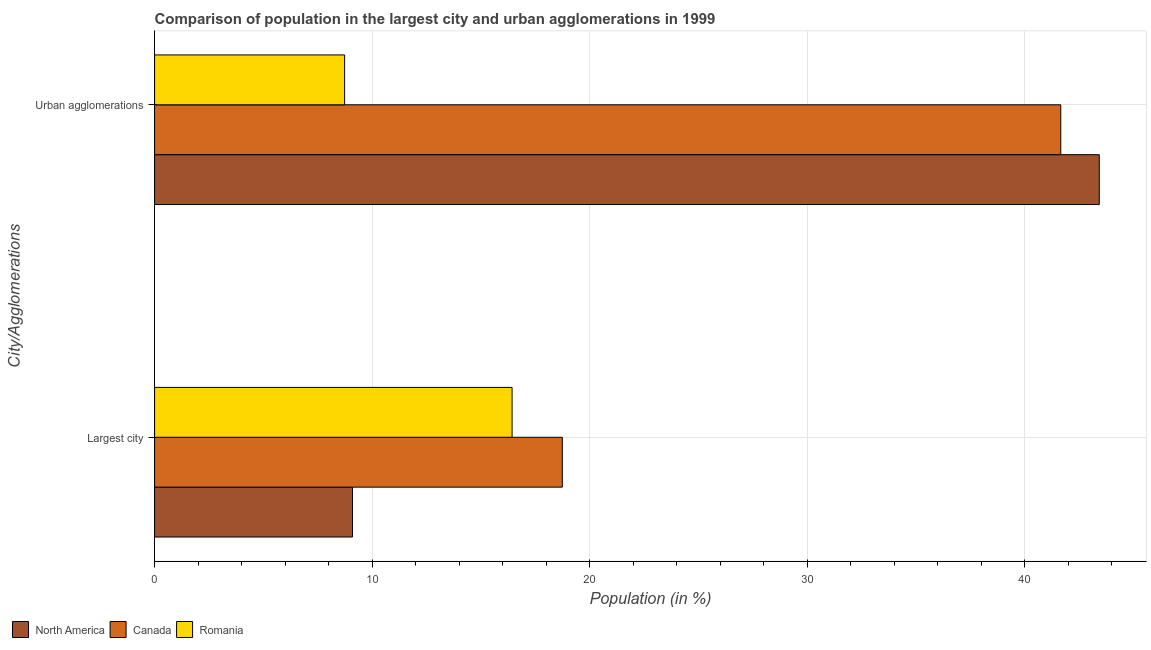How many different coloured bars are there?
Your answer should be very brief. 3. Are the number of bars per tick equal to the number of legend labels?
Provide a short and direct response. Yes. How many bars are there on the 2nd tick from the bottom?
Give a very brief answer. 3. What is the label of the 1st group of bars from the top?
Your answer should be compact. Urban agglomerations. What is the population in the largest city in North America?
Offer a very short reply. 9.1. Across all countries, what is the maximum population in urban agglomerations?
Provide a succinct answer. 43.42. Across all countries, what is the minimum population in the largest city?
Provide a succinct answer. 9.1. In which country was the population in urban agglomerations minimum?
Make the answer very short. Romania. What is the total population in urban agglomerations in the graph?
Make the answer very short. 93.81. What is the difference between the population in the largest city in Canada and that in Romania?
Your answer should be compact. 2.31. What is the difference between the population in urban agglomerations in Romania and the population in the largest city in Canada?
Offer a very short reply. -10.01. What is the average population in urban agglomerations per country?
Provide a succinct answer. 31.27. What is the difference between the population in the largest city and population in urban agglomerations in North America?
Keep it short and to the point. -34.32. What is the ratio of the population in urban agglomerations in Canada to that in North America?
Offer a very short reply. 0.96. Is the population in the largest city in North America less than that in Canada?
Your answer should be compact. Yes. What does the 3rd bar from the top in Largest city represents?
Ensure brevity in your answer.  North America. What does the 3rd bar from the bottom in Largest city represents?
Ensure brevity in your answer.  Romania. Does the graph contain any zero values?
Make the answer very short. No. Does the graph contain grids?
Offer a very short reply. Yes. Where does the legend appear in the graph?
Keep it short and to the point. Bottom left. How are the legend labels stacked?
Offer a very short reply. Horizontal. What is the title of the graph?
Make the answer very short. Comparison of population in the largest city and urban agglomerations in 1999. What is the label or title of the X-axis?
Ensure brevity in your answer.  Population (in %). What is the label or title of the Y-axis?
Provide a short and direct response. City/Agglomerations. What is the Population (in %) of North America in Largest city?
Your answer should be very brief. 9.1. What is the Population (in %) in Canada in Largest city?
Provide a short and direct response. 18.74. What is the Population (in %) in Romania in Largest city?
Offer a very short reply. 16.43. What is the Population (in %) in North America in Urban agglomerations?
Your answer should be compact. 43.42. What is the Population (in %) of Canada in Urban agglomerations?
Your response must be concise. 41.65. What is the Population (in %) in Romania in Urban agglomerations?
Offer a terse response. 8.74. Across all City/Agglomerations, what is the maximum Population (in %) in North America?
Make the answer very short. 43.42. Across all City/Agglomerations, what is the maximum Population (in %) of Canada?
Provide a short and direct response. 41.65. Across all City/Agglomerations, what is the maximum Population (in %) in Romania?
Your response must be concise. 16.43. Across all City/Agglomerations, what is the minimum Population (in %) in North America?
Ensure brevity in your answer.  9.1. Across all City/Agglomerations, what is the minimum Population (in %) of Canada?
Your answer should be very brief. 18.74. Across all City/Agglomerations, what is the minimum Population (in %) in Romania?
Keep it short and to the point. 8.74. What is the total Population (in %) of North America in the graph?
Offer a very short reply. 52.52. What is the total Population (in %) in Canada in the graph?
Offer a terse response. 60.39. What is the total Population (in %) of Romania in the graph?
Keep it short and to the point. 25.17. What is the difference between the Population (in %) of North America in Largest city and that in Urban agglomerations?
Make the answer very short. -34.32. What is the difference between the Population (in %) of Canada in Largest city and that in Urban agglomerations?
Keep it short and to the point. -22.91. What is the difference between the Population (in %) of Romania in Largest city and that in Urban agglomerations?
Keep it short and to the point. 7.7. What is the difference between the Population (in %) in North America in Largest city and the Population (in %) in Canada in Urban agglomerations?
Offer a terse response. -32.56. What is the difference between the Population (in %) in North America in Largest city and the Population (in %) in Romania in Urban agglomerations?
Your answer should be very brief. 0.36. What is the difference between the Population (in %) in Canada in Largest city and the Population (in %) in Romania in Urban agglomerations?
Offer a very short reply. 10.01. What is the average Population (in %) in North America per City/Agglomerations?
Provide a short and direct response. 26.26. What is the average Population (in %) of Canada per City/Agglomerations?
Offer a terse response. 30.2. What is the average Population (in %) in Romania per City/Agglomerations?
Your response must be concise. 12.58. What is the difference between the Population (in %) in North America and Population (in %) in Canada in Largest city?
Your response must be concise. -9.64. What is the difference between the Population (in %) in North America and Population (in %) in Romania in Largest city?
Make the answer very short. -7.34. What is the difference between the Population (in %) in Canada and Population (in %) in Romania in Largest city?
Your answer should be very brief. 2.31. What is the difference between the Population (in %) of North America and Population (in %) of Canada in Urban agglomerations?
Make the answer very short. 1.77. What is the difference between the Population (in %) of North America and Population (in %) of Romania in Urban agglomerations?
Keep it short and to the point. 34.69. What is the difference between the Population (in %) in Canada and Population (in %) in Romania in Urban agglomerations?
Keep it short and to the point. 32.92. What is the ratio of the Population (in %) of North America in Largest city to that in Urban agglomerations?
Ensure brevity in your answer.  0.21. What is the ratio of the Population (in %) of Canada in Largest city to that in Urban agglomerations?
Provide a short and direct response. 0.45. What is the ratio of the Population (in %) of Romania in Largest city to that in Urban agglomerations?
Provide a succinct answer. 1.88. What is the difference between the highest and the second highest Population (in %) in North America?
Your response must be concise. 34.32. What is the difference between the highest and the second highest Population (in %) in Canada?
Make the answer very short. 22.91. What is the difference between the highest and the second highest Population (in %) of Romania?
Provide a short and direct response. 7.7. What is the difference between the highest and the lowest Population (in %) of North America?
Provide a short and direct response. 34.32. What is the difference between the highest and the lowest Population (in %) in Canada?
Your answer should be compact. 22.91. What is the difference between the highest and the lowest Population (in %) in Romania?
Offer a very short reply. 7.7. 